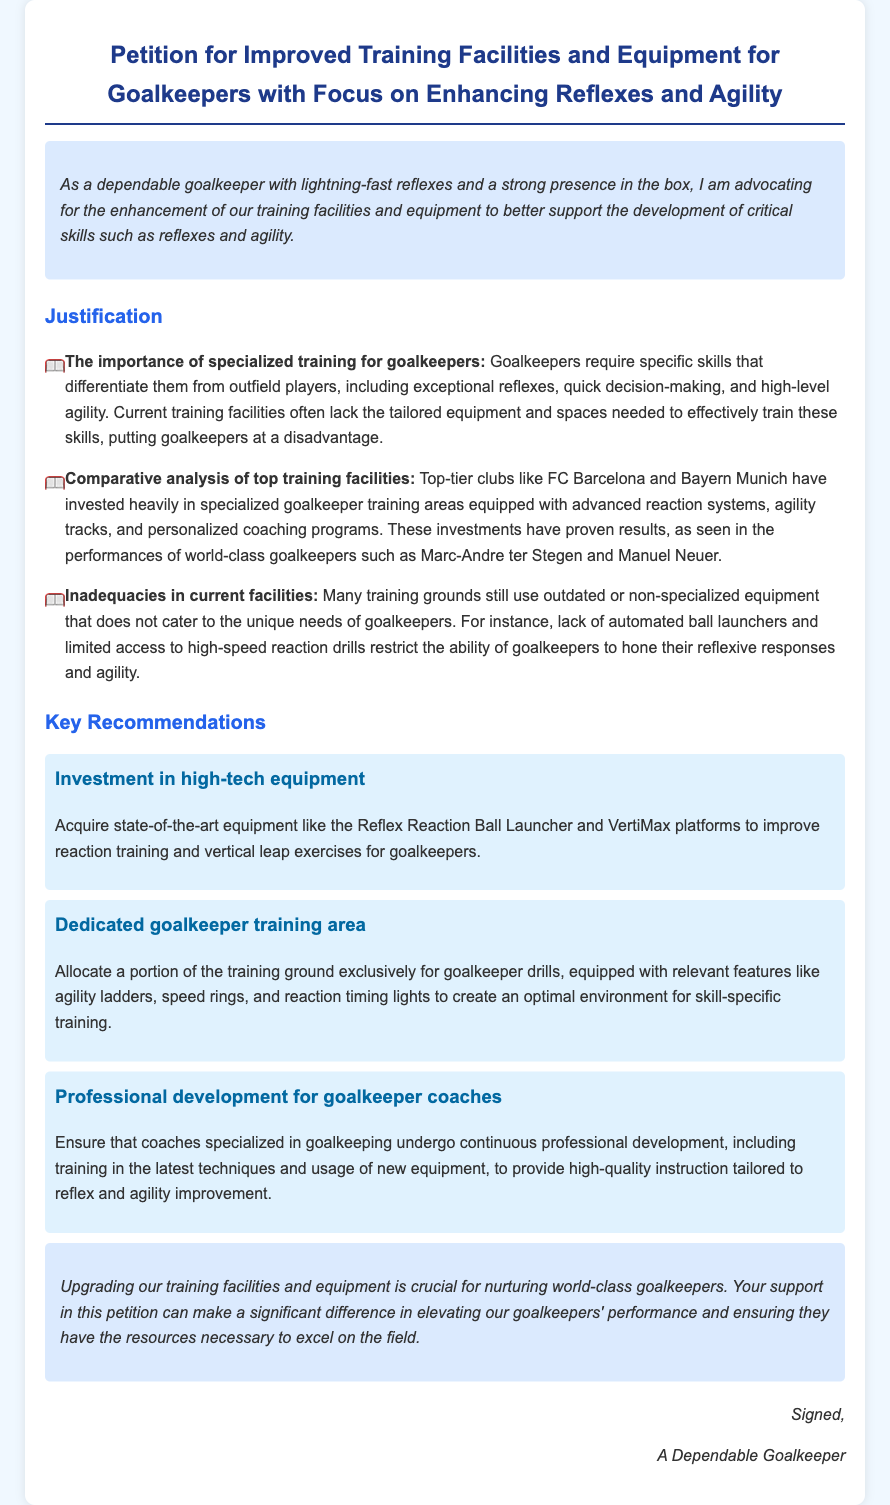What is the title of the petition? The title is explicitly stated at the start of the document, summarizing the focus of the request.
Answer: Petition for Improved Training Facilities and Equipment for Goalkeepers with Focus on Enhancing Reflexes and Agility Who is advocating for the petition? The introduction identifies the advocate for the petition, giving context on their perspective.
Answer: A dependable goalkeeper What are the top-tier clubs mentioned? The document specifically references well-known clubs that have invested in goalkeeper training facilities as a comparison.
Answer: FC Barcelona and Bayern Munich What type of equipment is recommended for improving reaction training? The document lists specific state-of-the-art equipment that should be acquired for training enhancement.
Answer: Reflex Reaction Ball Launcher What is a key recommendation for coaches? The document emphasizes the importance of ongoing education for those who coach goalkeepers to stay updated on techniques.
Answer: Professional development for goalkeeper coaches How has the investment in training facilities affected performances? The document states that the investments made by top clubs have led to observable improvements in goalkeeper performance.
Answer: Proven results What is a specific inadequacy mentioned in current facilities? The document highlights a particular limitation prevalent in many current training grounds that affects goalkeeper training.
Answer: Outdated or non-specialized equipment What is the purpose of the petition? The document summarizes the overall aim of the petition is to upgrade facilities and equipment for a specific group of players.
Answer: Upgrading training facilities Which skill areas are emphasized for goalkeepers? The document identifies key areas of focus for training in creating better goalkeepers.
Answer: Reflexes and agility 